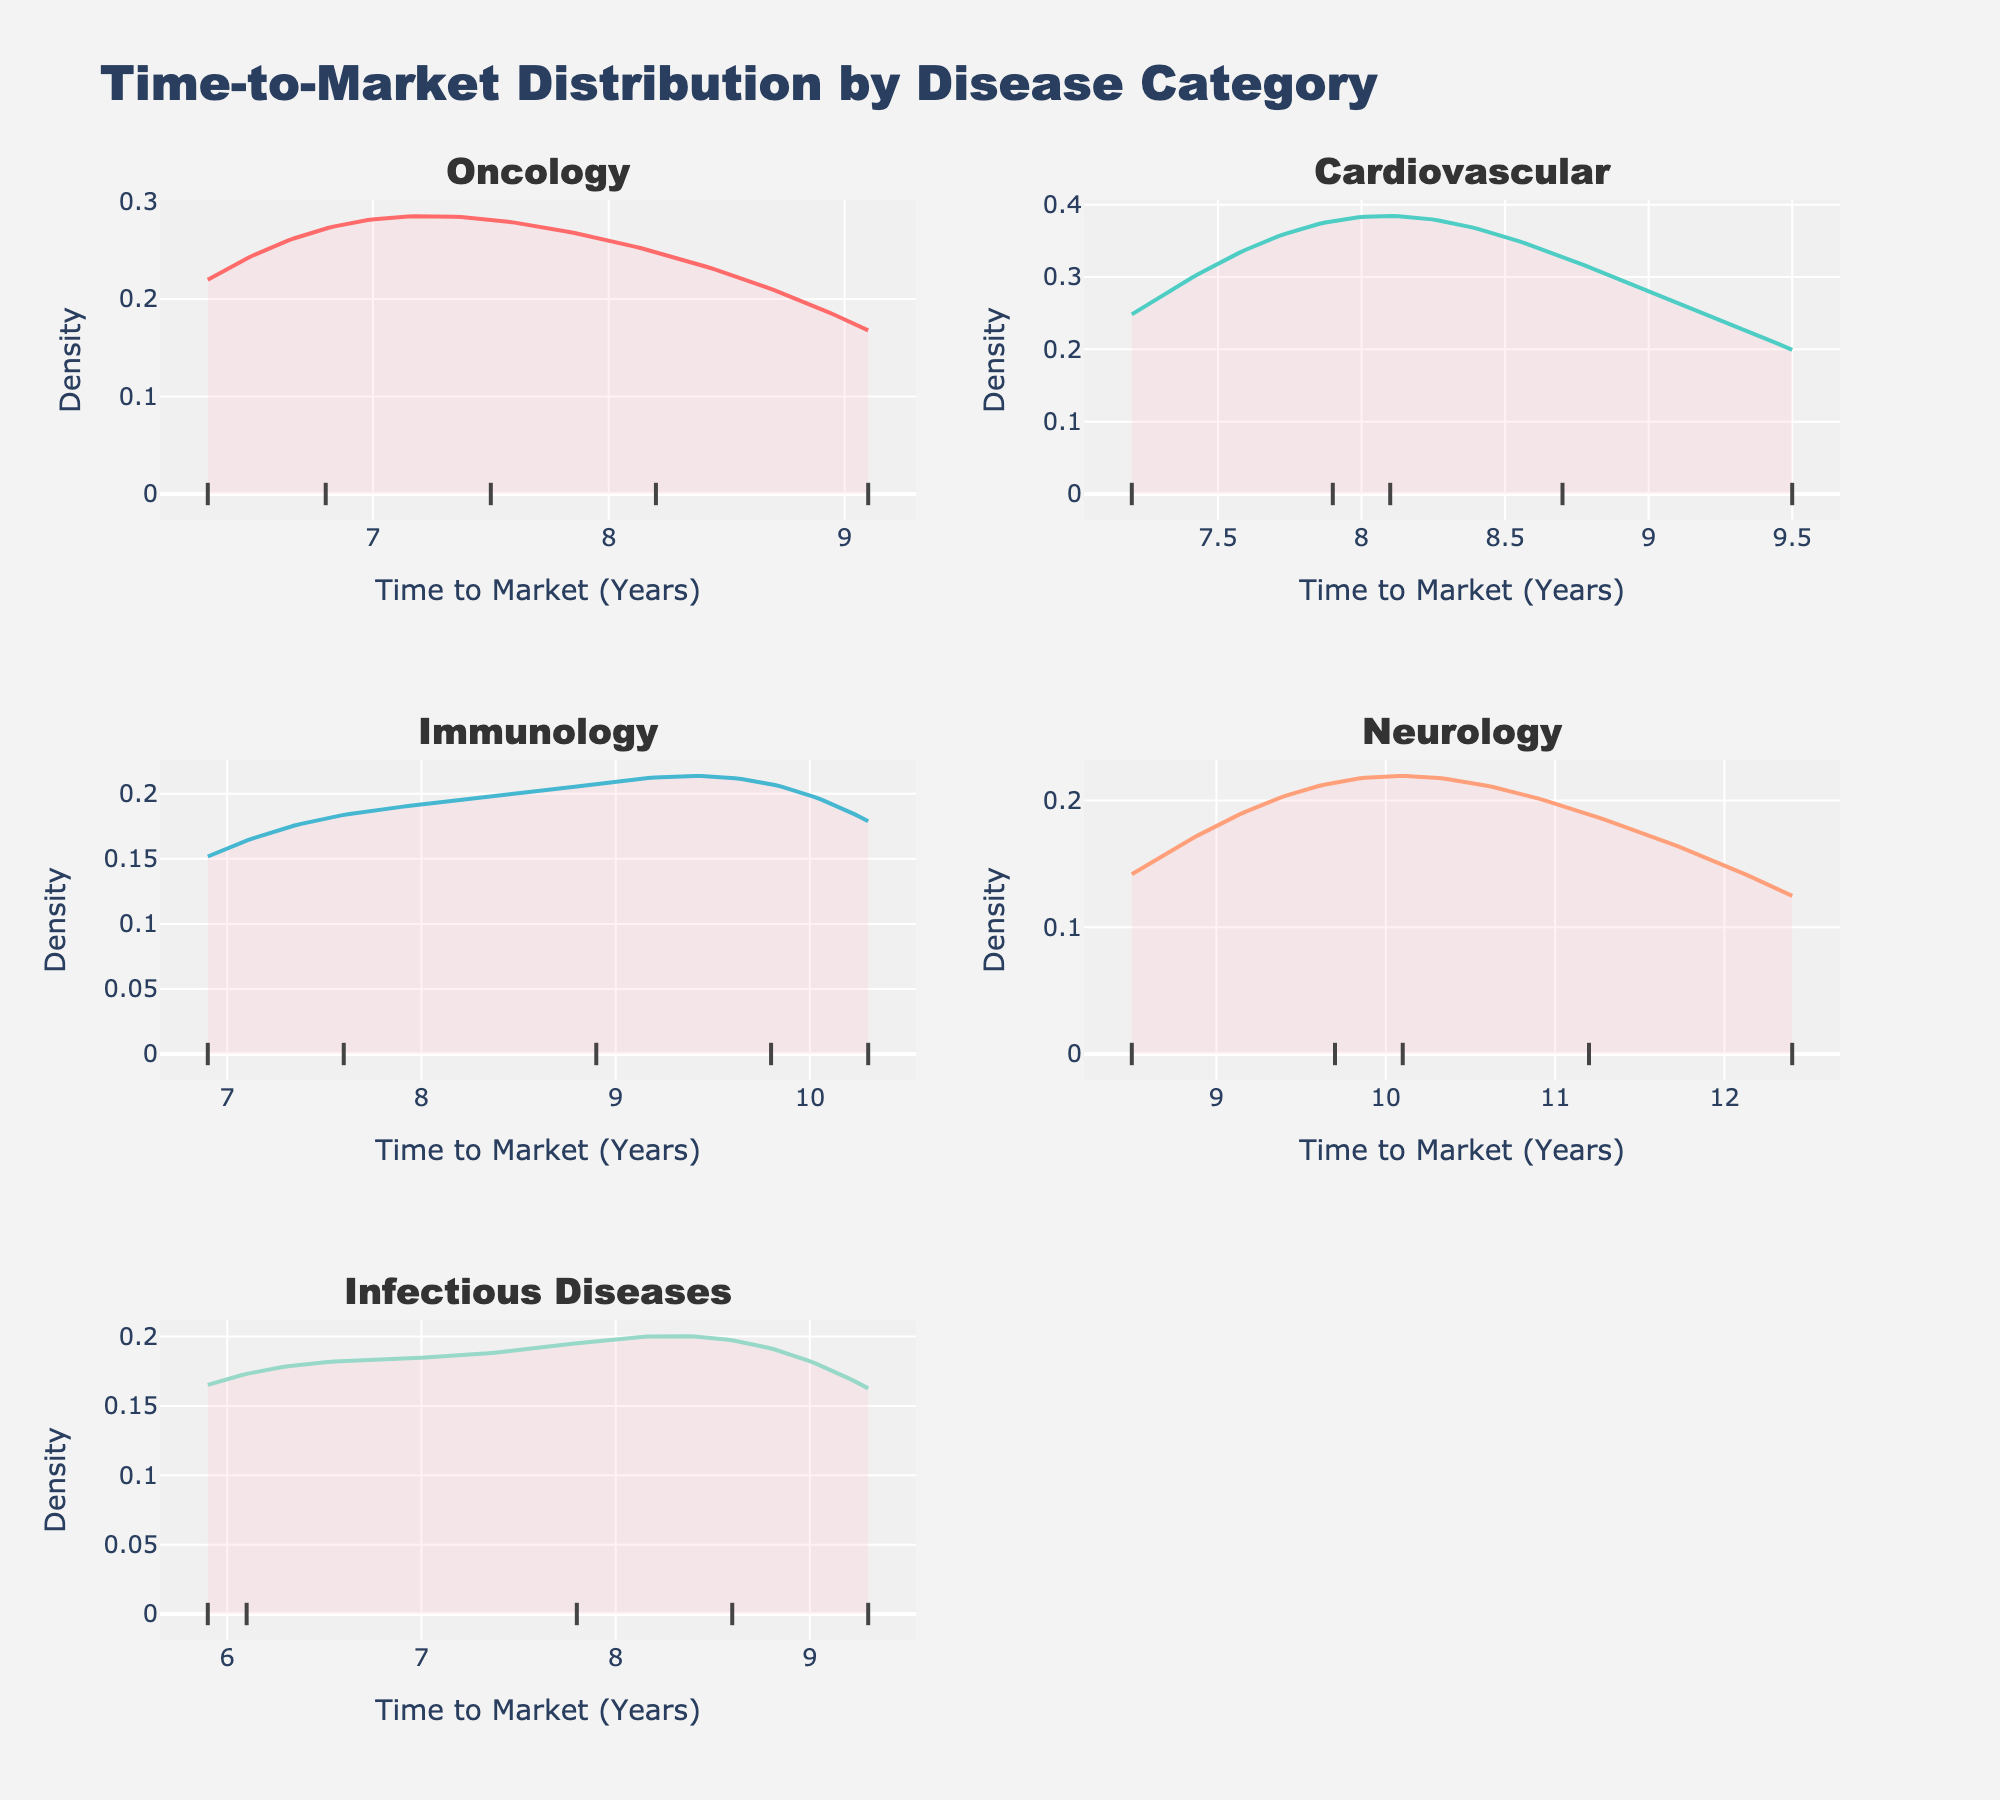What is the title of the figure? The title of the figure is located at the top center of the plot and is "Time-to-Market Distribution by Disease Category".
Answer: Time-to-Market Distribution by Disease Category Which category has the maximum range of time-to-market values in its density plot? By examining the breadth of the x-axis for each subplot, you can identify that the "Neurology" category has the widest spread, ranging from approximately 8.5 to 12.4 years.
Answer: Neurology How many disease categories is the figure divided into? The subplot titles clearly indicate that there are five different disease categories: Oncology, Cardiovascular, Immunology, Neurology, and Infectious Diseases.
Answer: Five Which subplot shows the shortest time-to-market value? By looking at the x-axis range in each subplot, it is evident that the "Infectious Diseases" plot contains the shortest time-to-market value, which is approximately 5.9 years.
Answer: Infectious Diseases In which disease category do most products take between 6 and 7.5 years to reach the market? Observing the peaks in the density plots, the "Oncology" category has the highest density peak between 6 and 7.5 years.
Answer: Oncology Which category shows the highest density peak across all the subplots? Visual comparison of the peaks reveals that the "Oncology" category has the highest peak, indicating a higher concentration of products being approved within its peak time range.
Answer: Oncology For the "Cardiovascular" category, what is the approximate range of time-to-market in years? By checking the x-axis of the "Cardiovascular" subplot, the range spans from roughly 7.2 years to 9.5 years.
Answer: 7.2 to 9.5 years Do any categories have a time-to-market that extends beyond 10 years? Examining the density plots shows that both "Immunology" and "Neurology" categories have products with time-to-market values extending beyond 10 years.
Answer: Immunology and Neurology Compare the "Immunology" and "Infectious Diseases" categories. Which has a shorter shortest time-to-market value, and by how much? The shortest time-to-market for "Immunology" is close to 6.9 years, while for "Infectious Diseases" it is about 5.9 years. Thus, "Infectious Diseases" has a shorter shortest time-to-market by approximately 1 year.
Answer: Infectious Diseases, by 1 year Which disease category has the most products with a similar time-to-market? By analyzing the density peaks, the "Oncology" category shows a high density peak, indicating that most products have a similar time-to-market, concentrated around the 6 to 8 year range.
Answer: Oncology 